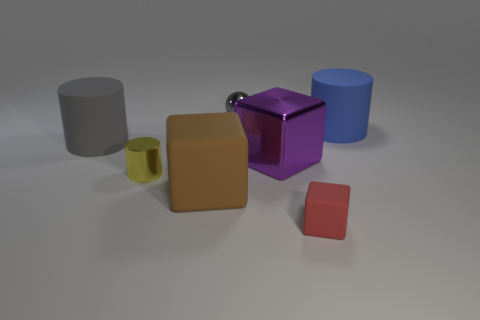Add 2 tiny red rubber objects. How many objects exist? 9 Subtract all balls. How many objects are left? 6 Subtract all metallic spheres. Subtract all metal cylinders. How many objects are left? 5 Add 1 tiny cylinders. How many tiny cylinders are left? 2 Add 7 large blocks. How many large blocks exist? 9 Subtract 0 cyan cylinders. How many objects are left? 7 